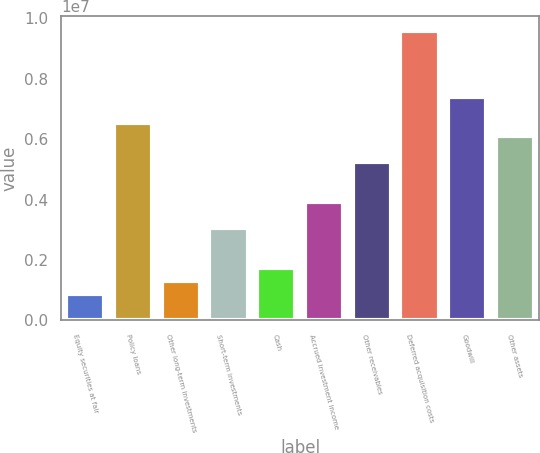Convert chart to OTSL. <chart><loc_0><loc_0><loc_500><loc_500><bar_chart><fcel>Equity securities at fair<fcel>Policy loans<fcel>Other long-term investments<fcel>Short-term investments<fcel>Cash<fcel>Accrued investment income<fcel>Other receivables<fcel>Deferred acquisition costs<fcel>Goodwill<fcel>Other assets<nl><fcel>872357<fcel>6.54268e+06<fcel>1.30854e+06<fcel>3.05325e+06<fcel>1.74471e+06<fcel>3.92561e+06<fcel>5.23414e+06<fcel>9.59593e+06<fcel>7.41504e+06<fcel>6.1065e+06<nl></chart> 